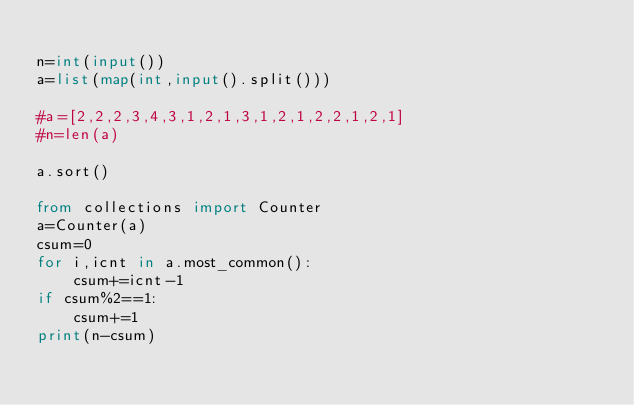<code> <loc_0><loc_0><loc_500><loc_500><_Python_>
n=int(input())
a=list(map(int,input().split()))

#a=[2,2,2,3,4,3,1,2,1,3,1,2,1,2,2,1,2,1]
#n=len(a)

a.sort()

from collections import Counter
a=Counter(a)
csum=0
for i,icnt in a.most_common():
    csum+=icnt-1
if csum%2==1:
    csum+=1
print(n-csum)
    </code> 